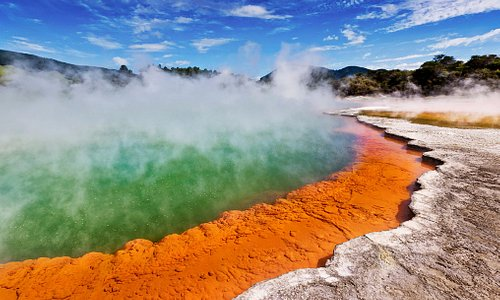Can you explain why the water is so brightly colored? The bright green color of the water in this hot spring is due to the high concentrations of minerals, particularly sulfur, which are dissolved in the water as it surfaces from underground volcanic activity. The orange and red shades along the edges are caused by different minerals, such as iron oxide, that precipitate out of the water and deposit around the spring. 